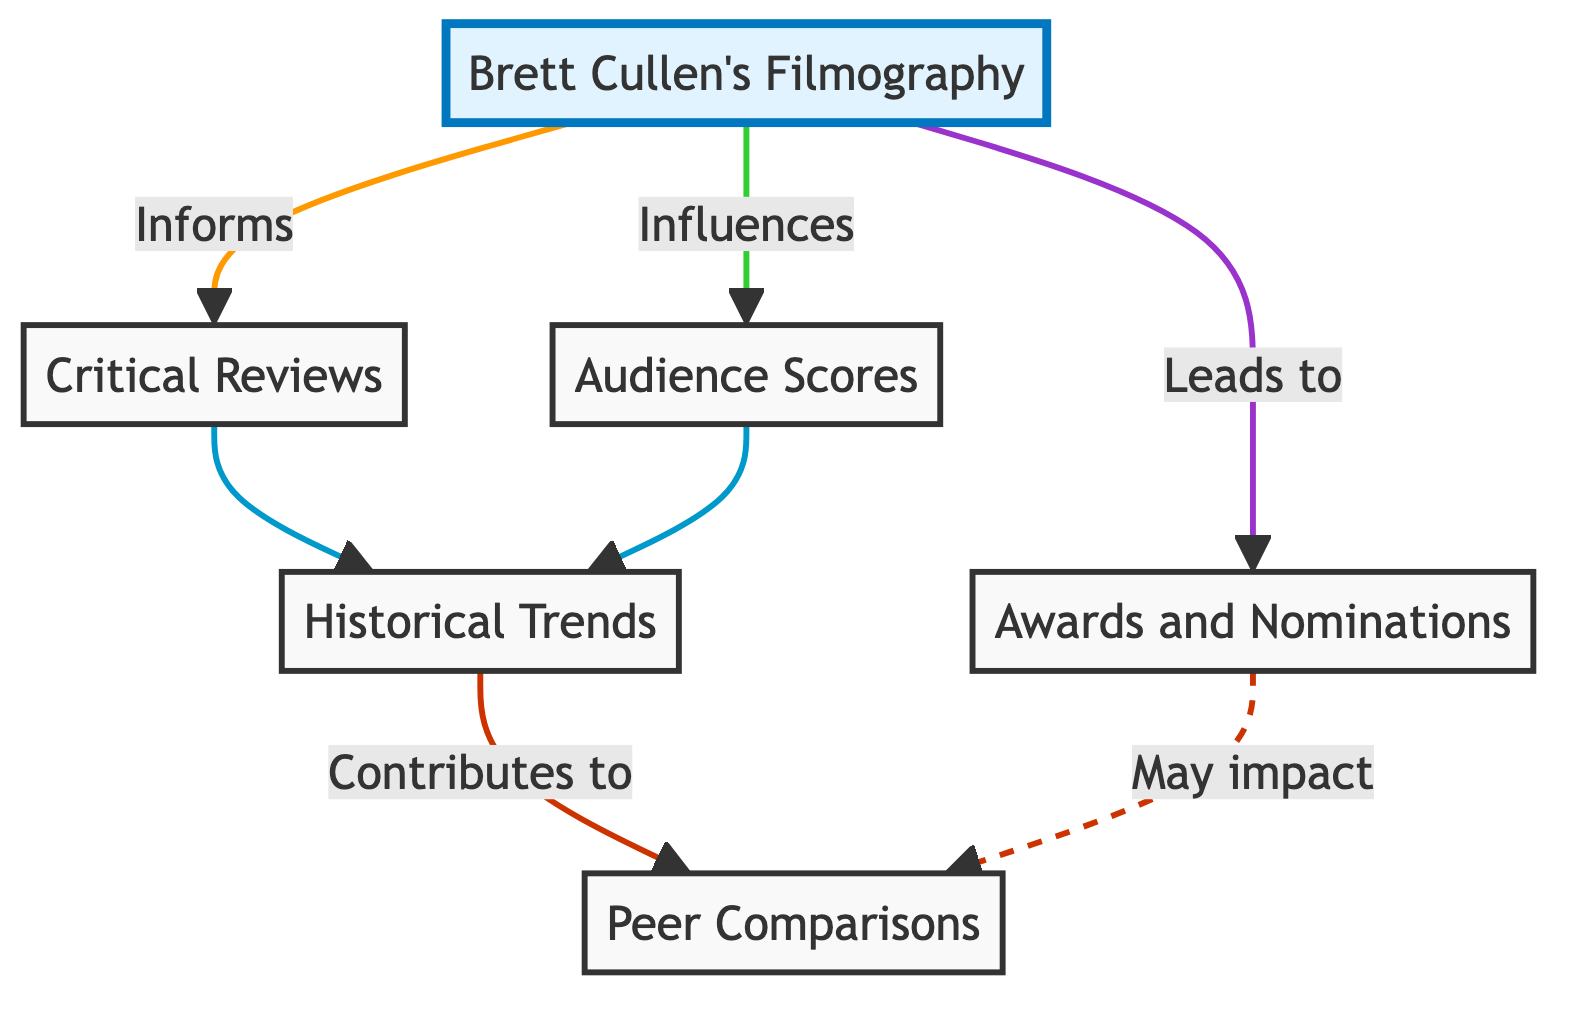What is the main node in the flow chart? The main node in the flow chart is "Brett Cullen's Filmography," indicated as the starting point of the flow. The flow chart visually emphasizes this node through a highlighted style, suggesting its importance as the basis for evaluating critical reception and audience scores.
Answer: Brett Cullen's Filmography How many nodes are present in the diagram? The diagram contains six nodes, including "Brett Cullen's Filmography," "Critical Reviews," "Audience Scores," "Awards and Nominations," "Historical Trends," and "Peer Comparisons." Each node represents a different aspect of the evaluation process.
Answer: 6 What does "Brett Cullen's Filmography" lead to? "Brett Cullen's Filmography" leads to "Critical Reviews," "Audience Scores," and "Awards and Nominations." These connections indicate the impact that Cullen's films have on the reception from critics and audiences, as well as the recognitions his work may receive.
Answer: Critical Reviews, Audience Scores, Awards and Nominations Which nodes inform "Historical Trends"? Both "Critical Reviews" and "Audience Scores" inform "Historical Trends." This shows that the trends in how Cullen's films are received over the years are influenced by both the critical reception and audience feedback, creating a comprehensive understanding of his work's evolution.
Answer: Critical Reviews, Audience Scores What is the relationship between "Awards and Nominations" and "Peer Comparisons"? The relationship between "Awards and Nominations" and "Peer Comparisons" is indicated by a dashed line labeled "May impact." This suggests that while awards and nominations can influence peer comparisons, the connection is not as direct or strong as with other nodes, indicating it’s a possible but not guaranteed effect.
Answer: May impact How do "Historical Trends" contribute to "Peer Comparisons"? "Historical Trends" contribute to "Peer Comparisons" as indicated by the flow line labeled "Contributes to." This signifies that the analysis of trends in critical and audience reception over time directly helps in comparing Brett Cullen's films with similar genre works.
Answer: Contributes to What are the sources mentioned for obtaining "Critical Reviews"? The sources mentioned for obtaining "Critical Reviews" include Rotten Tomatoes and Metacritic. This specifies the platforms used for analyzing professional critic opinions, which are critical for understanding reception.
Answer: Rotten Tomatoes and Metacritic Which node is indicated as influencing audience scores? "Brett Cullen's Filmography" is indicated as influencing audience scores. This highlights the connection between the films listed and how audiences perceive and score them overall based on that filmography.
Answer: Influences 